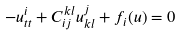<formula> <loc_0><loc_0><loc_500><loc_500>- u ^ { i } _ { t t } + C ^ { k l } _ { i j } u ^ { j } _ { k l } + f _ { i } ( u ) = 0</formula> 